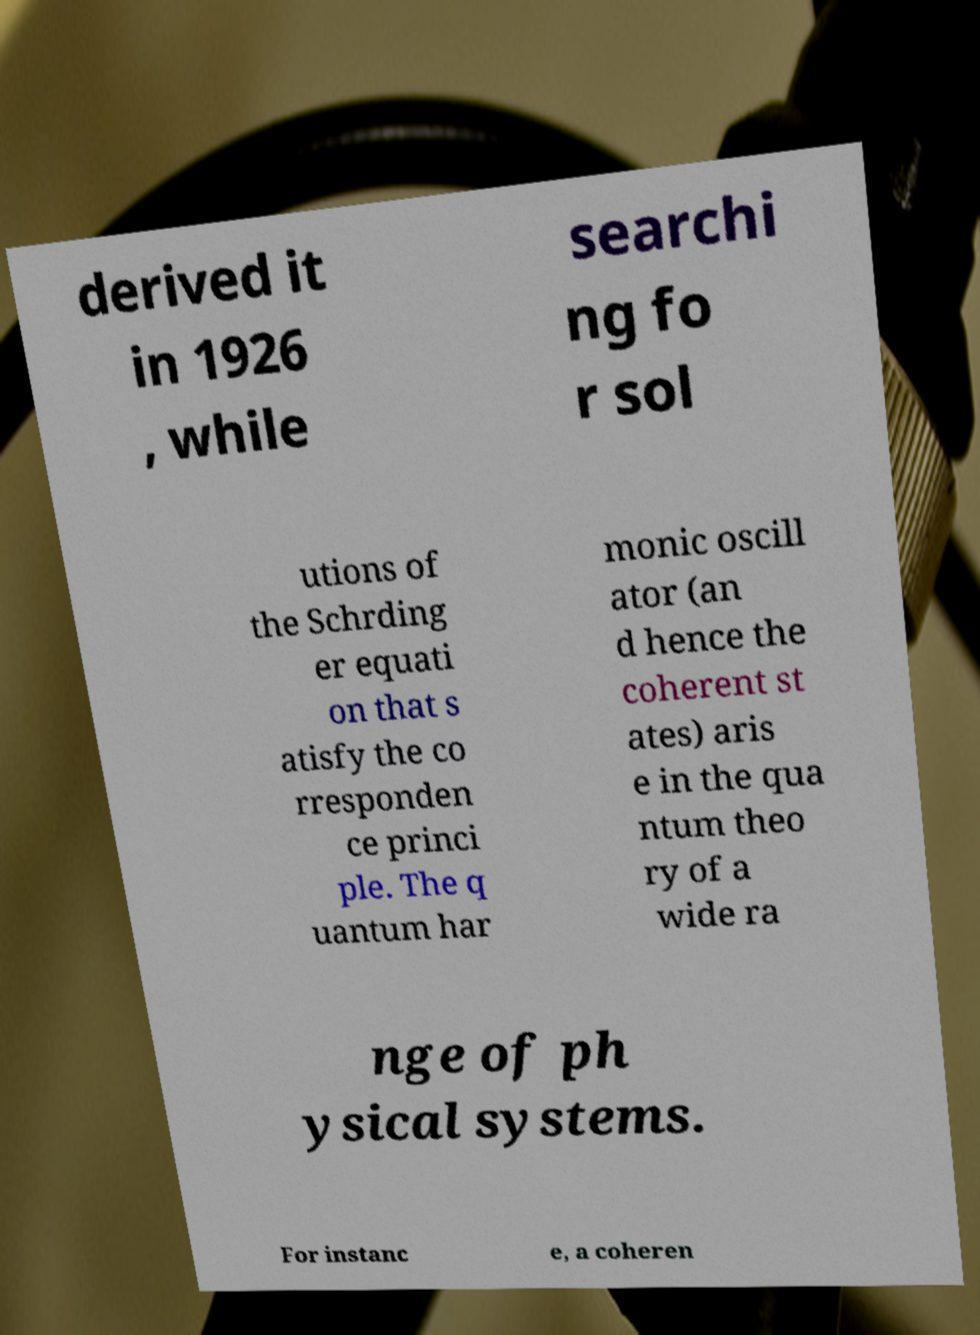Could you extract and type out the text from this image? derived it in 1926 , while searchi ng fo r sol utions of the Schrding er equati on that s atisfy the co rresponden ce princi ple. The q uantum har monic oscill ator (an d hence the coherent st ates) aris e in the qua ntum theo ry of a wide ra nge of ph ysical systems. For instanc e, a coheren 